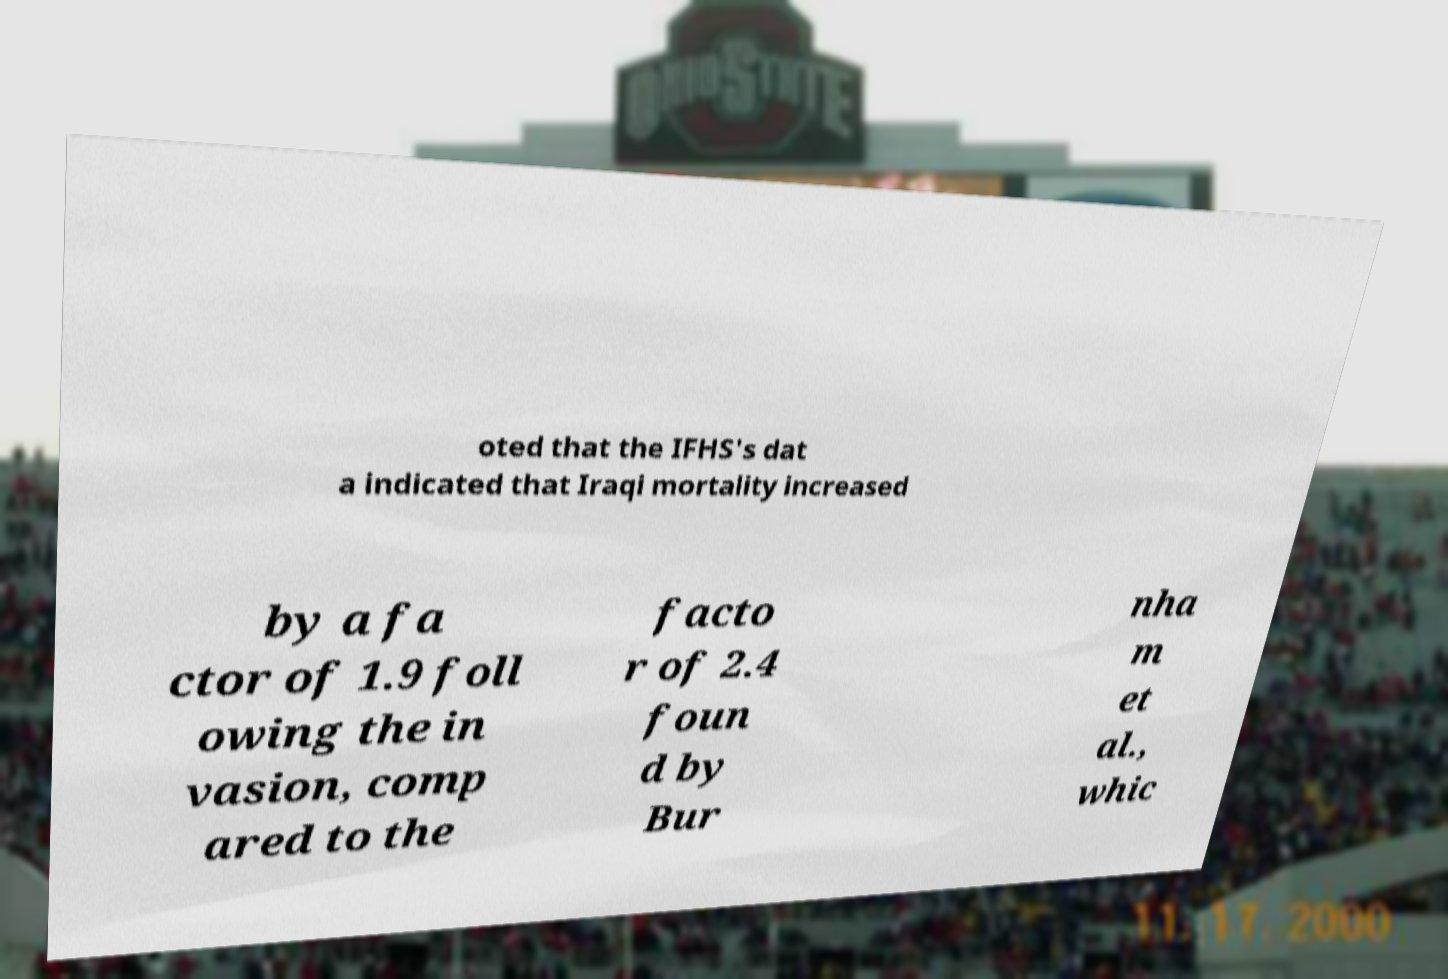There's text embedded in this image that I need extracted. Can you transcribe it verbatim? oted that the IFHS's dat a indicated that Iraqi mortality increased by a fa ctor of 1.9 foll owing the in vasion, comp ared to the facto r of 2.4 foun d by Bur nha m et al., whic 